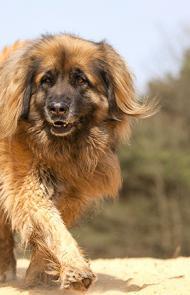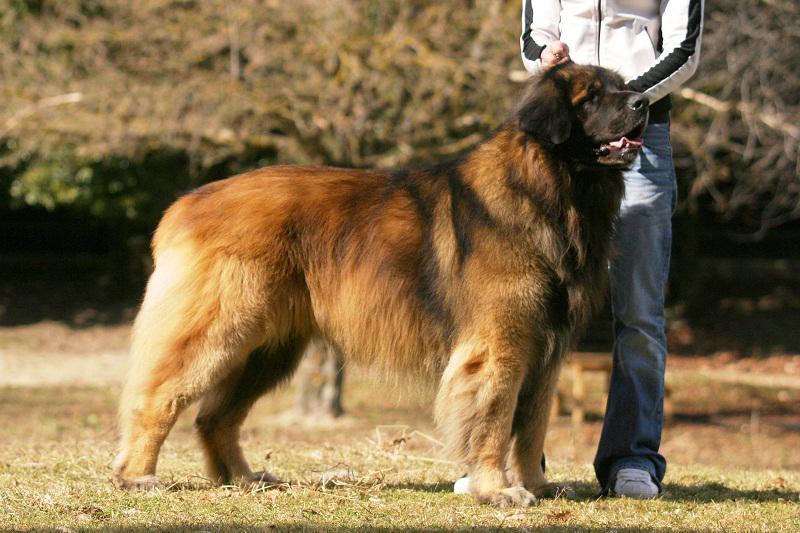The first image is the image on the left, the second image is the image on the right. For the images displayed, is the sentence "A person is posed with one big dog that is standing with its body turned rightward." factually correct? Answer yes or no. Yes. The first image is the image on the left, the second image is the image on the right. For the images displayed, is the sentence "A large dog is standing outdoors next to a human." factually correct? Answer yes or no. Yes. The first image is the image on the left, the second image is the image on the right. For the images displayed, is the sentence "Each dog's tongue is clearly visible." factually correct? Answer yes or no. No. 